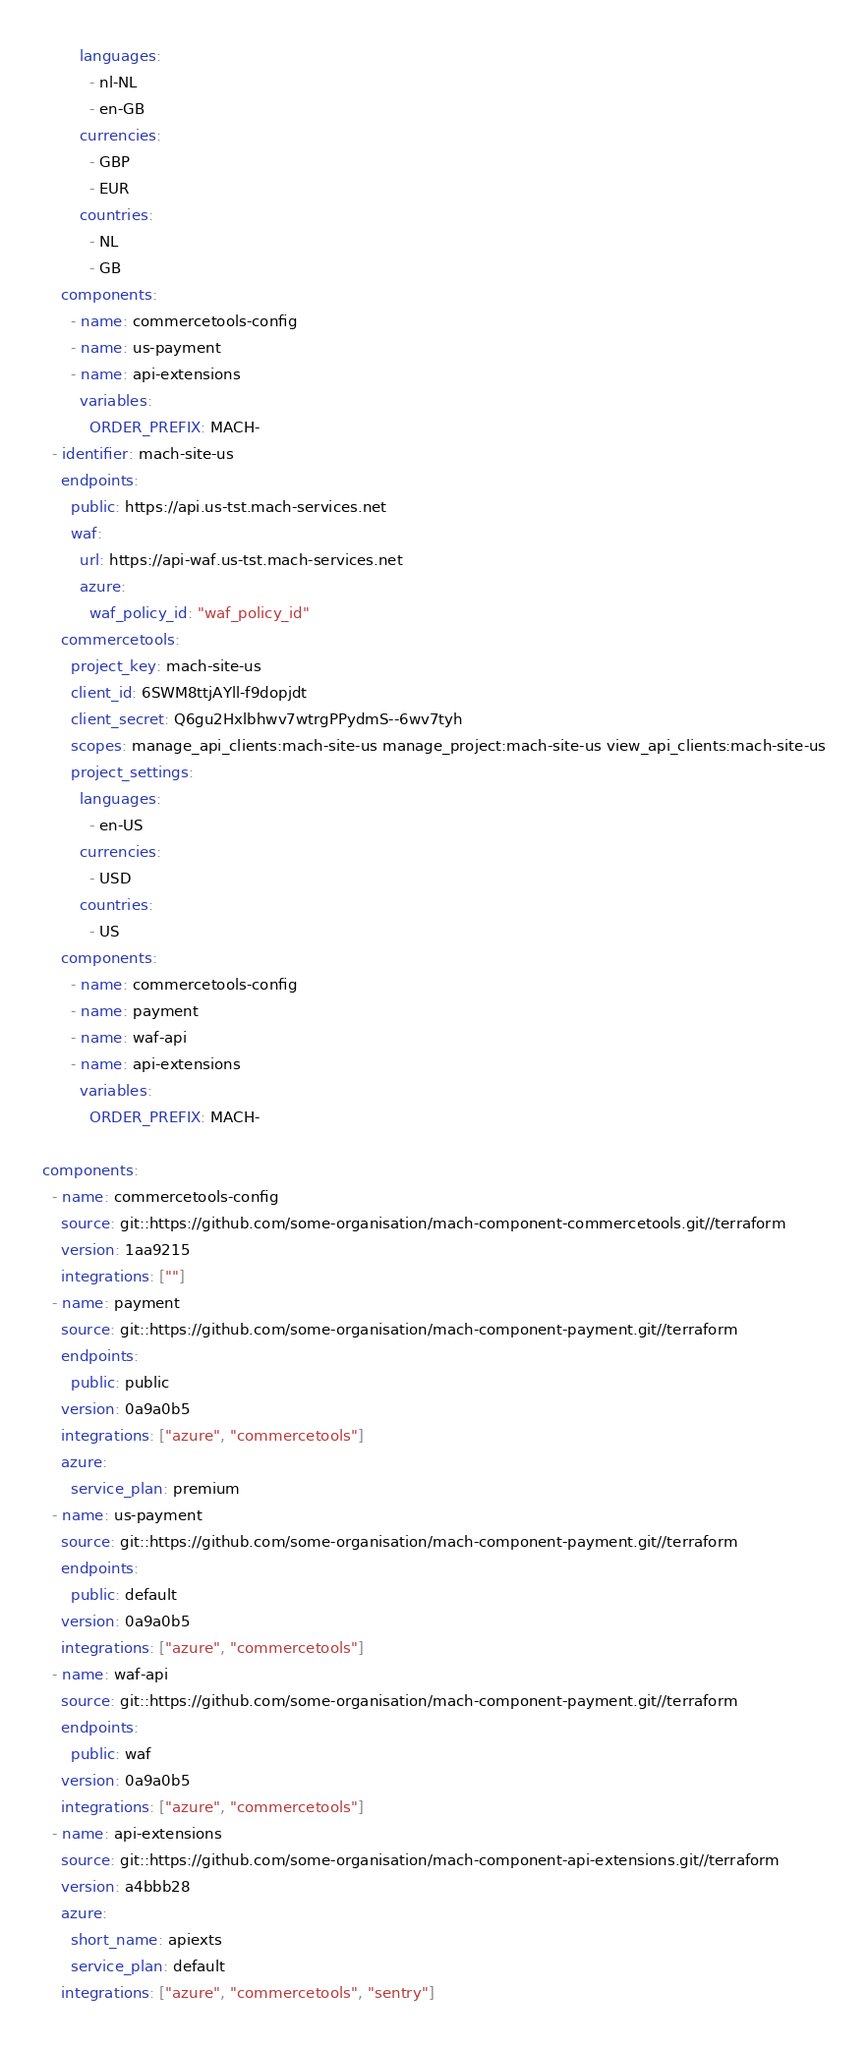Convert code to text. <code><loc_0><loc_0><loc_500><loc_500><_YAML_>        languages:
          - nl-NL
          - en-GB
        currencies:
          - GBP
          - EUR
        countries:
          - NL
          - GB
    components:
      - name: commercetools-config
      - name: us-payment
      - name: api-extensions
        variables:
          ORDER_PREFIX: MACH-
  - identifier: mach-site-us
    endpoints:
      public: https://api.us-tst.mach-services.net
      waf:
        url: https://api-waf.us-tst.mach-services.net
        azure:
          waf_policy_id: "waf_policy_id"
    commercetools:
      project_key: mach-site-us
      client_id: 6SWM8ttjAYll-f9dopjdt
      client_secret: Q6gu2Hxlbhwv7wtrgPPydmS--6wv7tyh
      scopes: manage_api_clients:mach-site-us manage_project:mach-site-us view_api_clients:mach-site-us
      project_settings:
        languages:
          - en-US
        currencies:
          - USD
        countries:
          - US
    components:
      - name: commercetools-config
      - name: payment
      - name: waf-api
      - name: api-extensions
        variables:
          ORDER_PREFIX: MACH-

components:
  - name: commercetools-config
    source: git::https://github.com/some-organisation/mach-component-commercetools.git//terraform
    version: 1aa9215
    integrations: [""]
  - name: payment
    source: git::https://github.com/some-organisation/mach-component-payment.git//terraform
    endpoints:
      public: public
    version: 0a9a0b5
    integrations: ["azure", "commercetools"]
    azure:
      service_plan: premium
  - name: us-payment
    source: git::https://github.com/some-organisation/mach-component-payment.git//terraform
    endpoints:
      public: default
    version: 0a9a0b5
    integrations: ["azure", "commercetools"]
  - name: waf-api
    source: git::https://github.com/some-organisation/mach-component-payment.git//terraform
    endpoints:
      public: waf
    version: 0a9a0b5
    integrations: ["azure", "commercetools"]
  - name: api-extensions
    source: git::https://github.com/some-organisation/mach-component-api-extensions.git//terraform
    version: a4bbb28
    azure:
      short_name: apiexts
      service_plan: default
    integrations: ["azure", "commercetools", "sentry"]
</code> 